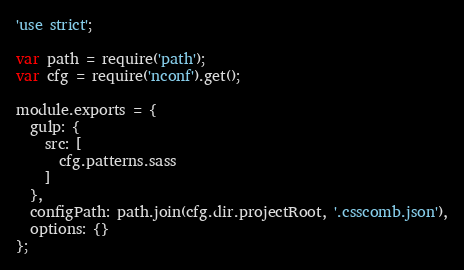Convert code to text. <code><loc_0><loc_0><loc_500><loc_500><_JavaScript_>'use strict';

var path = require('path');
var cfg = require('nconf').get();

module.exports = {
  gulp: {
    src: [
      cfg.patterns.sass
    ]
  },
  configPath: path.join(cfg.dir.projectRoot, '.csscomb.json'),
  options: {}
};
</code> 